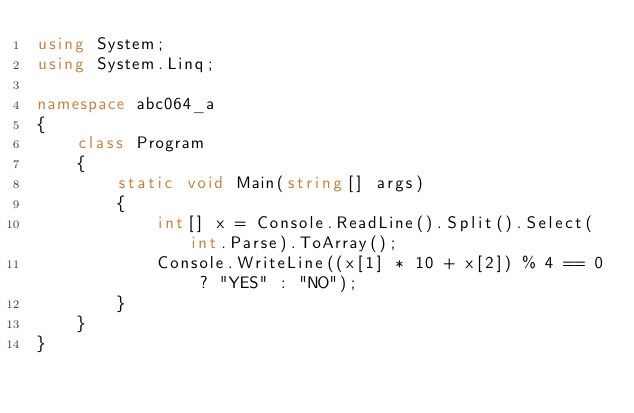Convert code to text. <code><loc_0><loc_0><loc_500><loc_500><_C#_>using System;
using System.Linq;

namespace abc064_a
{
    class Program
    {
        static void Main(string[] args)
        {
            int[] x = Console.ReadLine().Split().Select(int.Parse).ToArray();
            Console.WriteLine((x[1] * 10 + x[2]) % 4 == 0 ? "YES" : "NO");
        }
    }
}</code> 